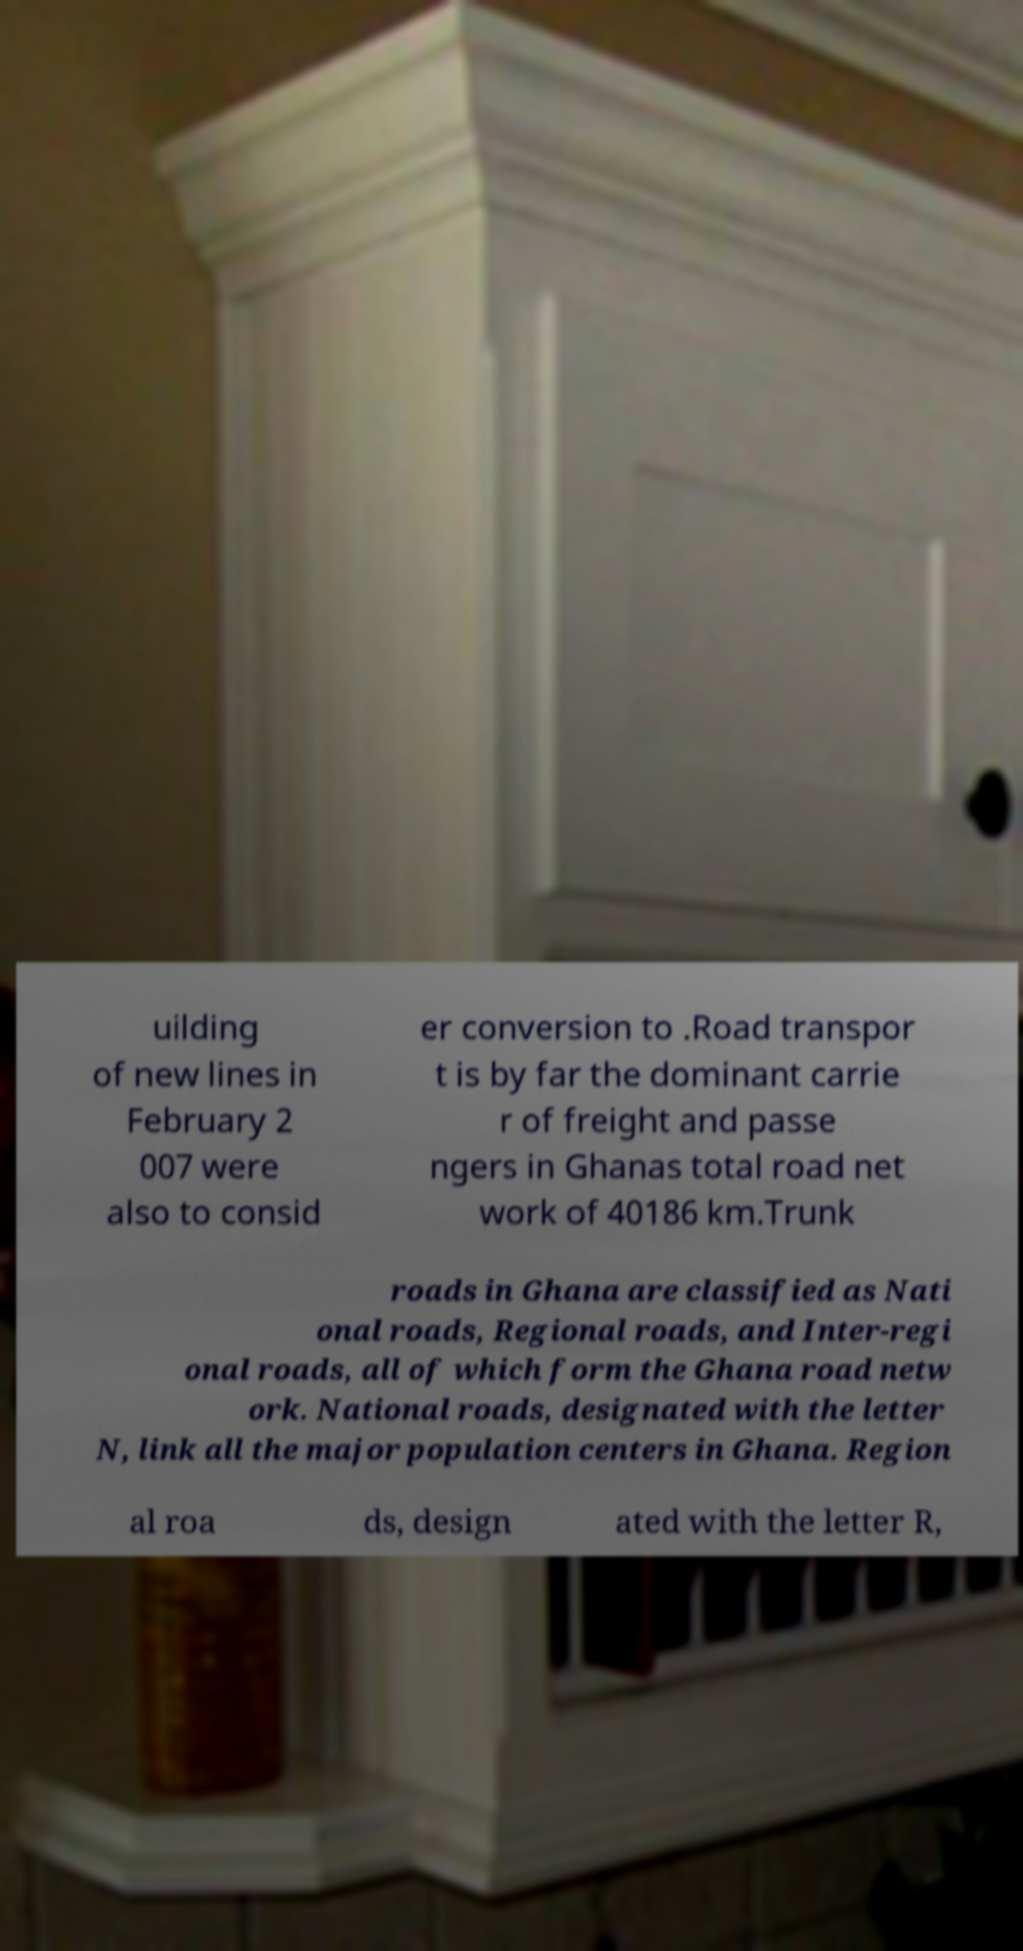Can you accurately transcribe the text from the provided image for me? uilding of new lines in February 2 007 were also to consid er conversion to .Road transpor t is by far the dominant carrie r of freight and passe ngers in Ghanas total road net work of 40186 km.Trunk roads in Ghana are classified as Nati onal roads, Regional roads, and Inter-regi onal roads, all of which form the Ghana road netw ork. National roads, designated with the letter N, link all the major population centers in Ghana. Region al roa ds, design ated with the letter R, 